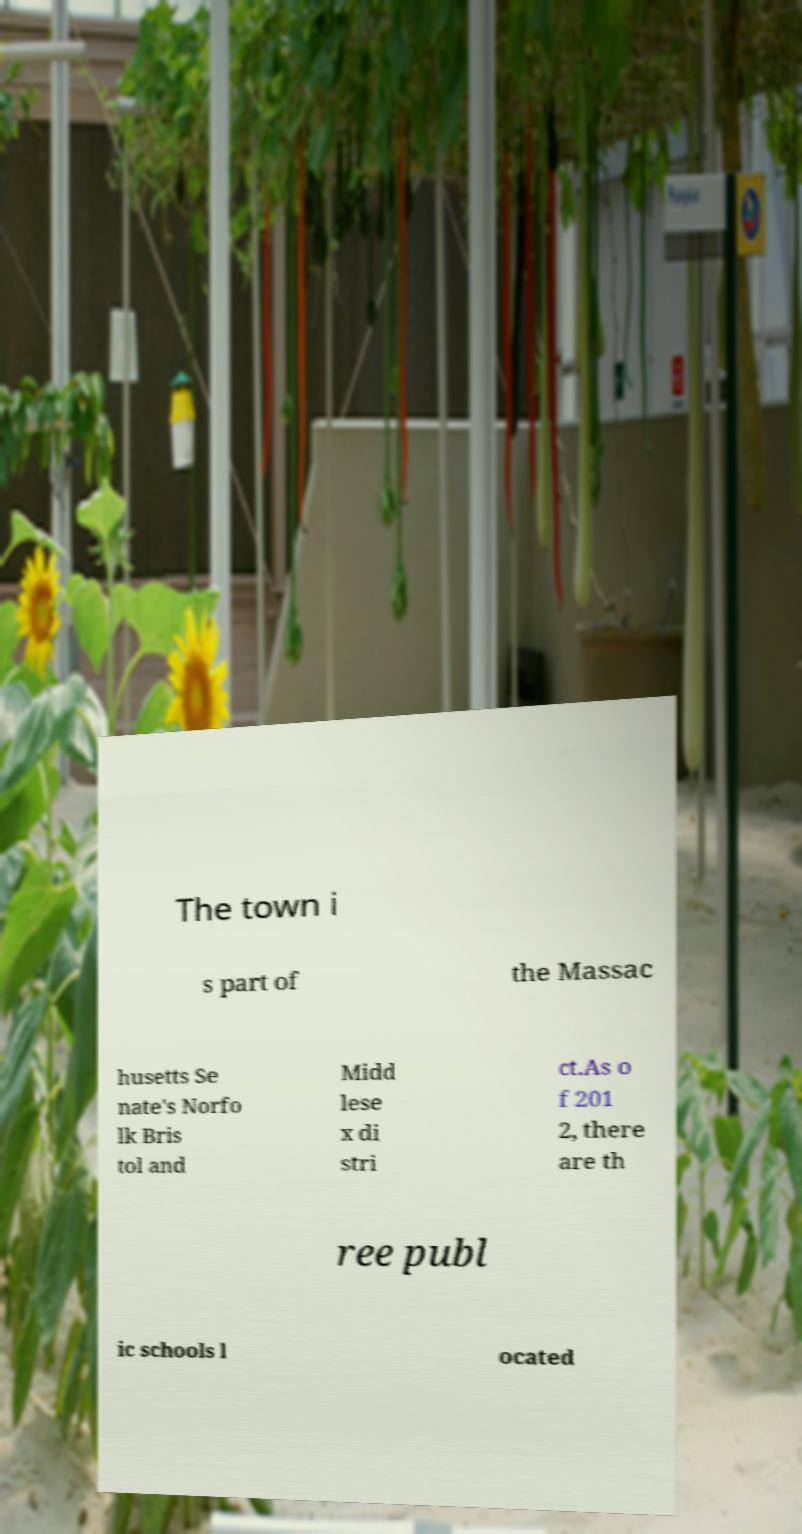Could you assist in decoding the text presented in this image and type it out clearly? The town i s part of the Massac husetts Se nate's Norfo lk Bris tol and Midd lese x di stri ct.As o f 201 2, there are th ree publ ic schools l ocated 